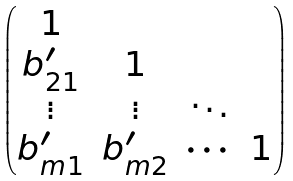<formula> <loc_0><loc_0><loc_500><loc_500>\begin{pmatrix} 1 \\ b ^ { \prime } _ { 2 1 } & 1 \\ \vdots & \vdots & \ddots \\ b ^ { \prime } _ { m 1 } & b ^ { \prime } _ { m 2 } & \cdots & 1 \end{pmatrix}</formula> 